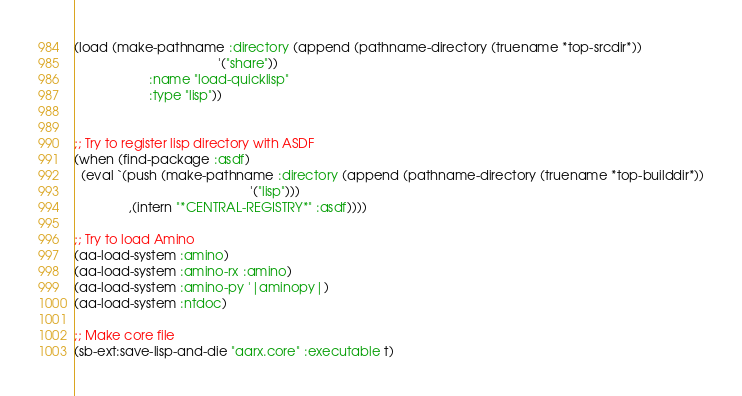Convert code to text. <code><loc_0><loc_0><loc_500><loc_500><_Lisp_>(load (make-pathname :directory (append (pathname-directory (truename *top-srcdir*))
                                        '("share"))
                     :name "load-quicklisp"
                     :type "lisp"))


;; Try to register lisp directory with ASDF
(when (find-package :asdf)
  (eval `(push (make-pathname :directory (append (pathname-directory (truename *top-builddir*))
                                                 '("lisp")))
               ,(intern "*CENTRAL-REGISTRY*" :asdf))))

;; Try to load Amino
(aa-load-system :amino)
(aa-load-system :amino-rx :amino)
(aa-load-system :amino-py '|aminopy|)
(aa-load-system :ntdoc)

;; Make core file
(sb-ext:save-lisp-and-die "aarx.core" :executable t)
</code> 